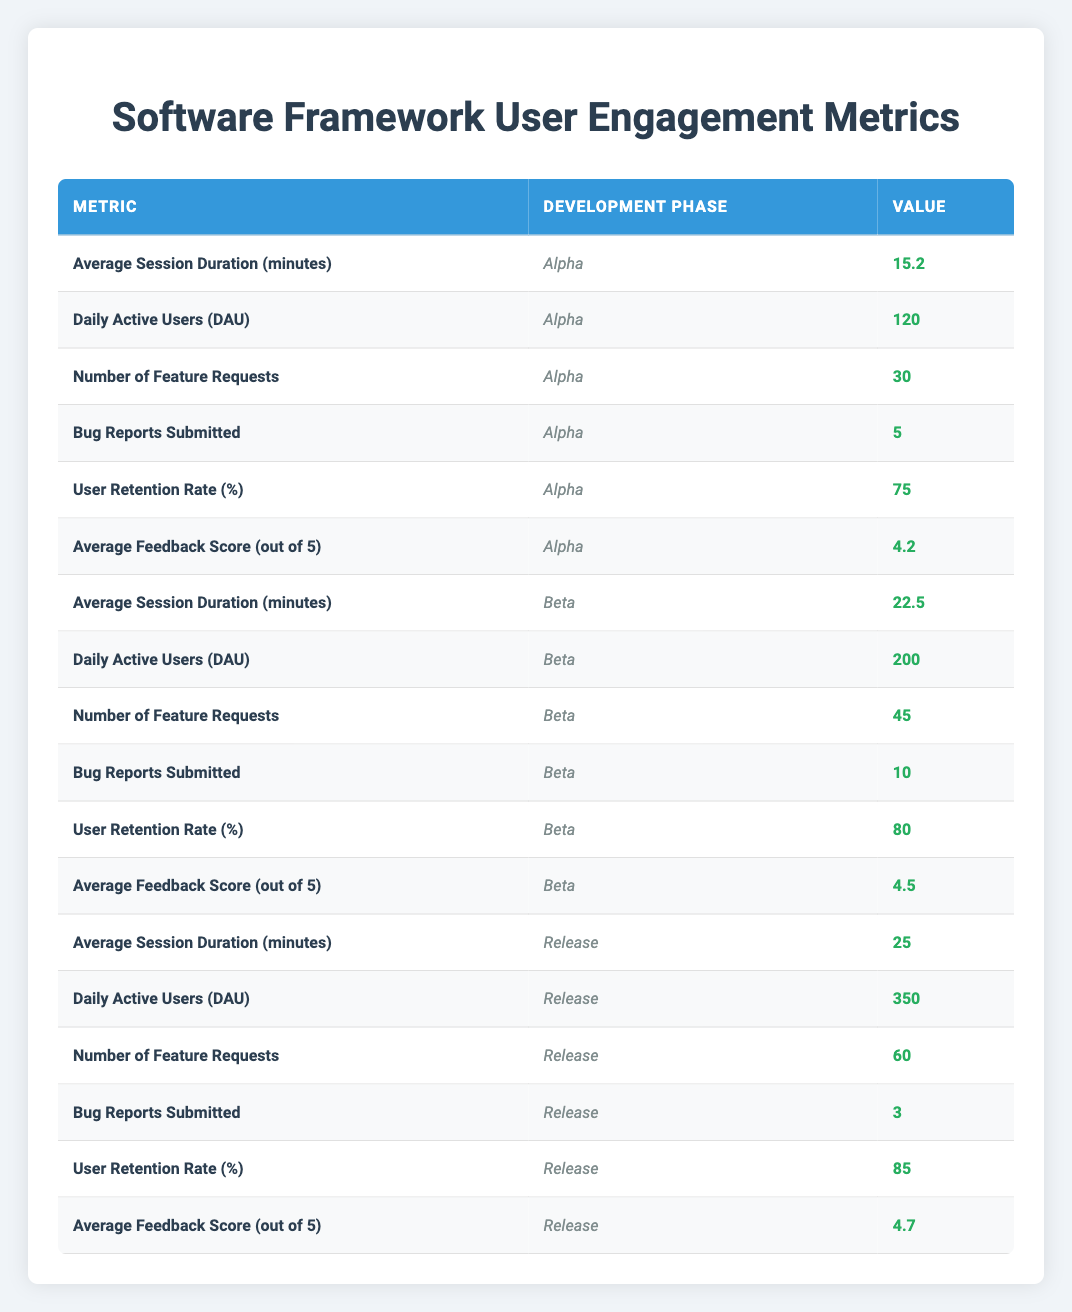What is the Average Session Duration in the Beta phase? In the Beta phase, the Average Session Duration is listed in the table as 22.5 minutes.
Answer: 22.5 minutes How many Bug Reports were submitted during the Alpha phase? The table indicates that 5 Bug Reports were submitted during the Alpha phase.
Answer: 5 What is the total number of Daily Active Users across all phases? The total number of Daily Active Users can be calculated by summing the DAU values for each phase: 120 (Alpha) + 200 (Beta) + 350 (Release) = 670.
Answer: 670 Is the User Retention Rate higher in the Release phase than in the Alpha phase? In the Release phase, the User Retention Rate is 85%, while in the Alpha phase, it is 75%. Since 85% is greater than 75%, the statement is true.
Answer: Yes What is the difference in Average Feedback Score between the Beta and Release phases? The Average Feedback Score in the Beta phase is 4.5 and in the Release phase is 4.7. The difference is 4.7 - 4.5 = 0.2.
Answer: 0.2 Which phase had the highest number of Feature Requests and how many were there? According to the table, the Release phase had the highest number of Feature Requests, with a total of 60.
Answer: Release phase, 60 What is the average Average Session Duration across all three phases? To calculate the average, we sum the Average Session Durations: (15.2 + 22.5 + 25) and divide by the number of phases (3). This gives (62.7 / 3) = 20.9 minutes.
Answer: 20.9 minutes Was the Daily Active Users count highest in the Beta phase? In the Beta phase, the DAU was recorded as 200, while in the Release phase it is 350. Therefore, the Beta phase did not have the highest DAU count.
Answer: No How many Bug Reports were submitted in the Release phase compared to the Beta phase? The table shows that 10 Bug Reports were submitted in the Beta phase and 3 in the Release phase. Therefore, the Beta phase had more Bug Reports.
Answer: Beta phase had more, 10 vs 3 